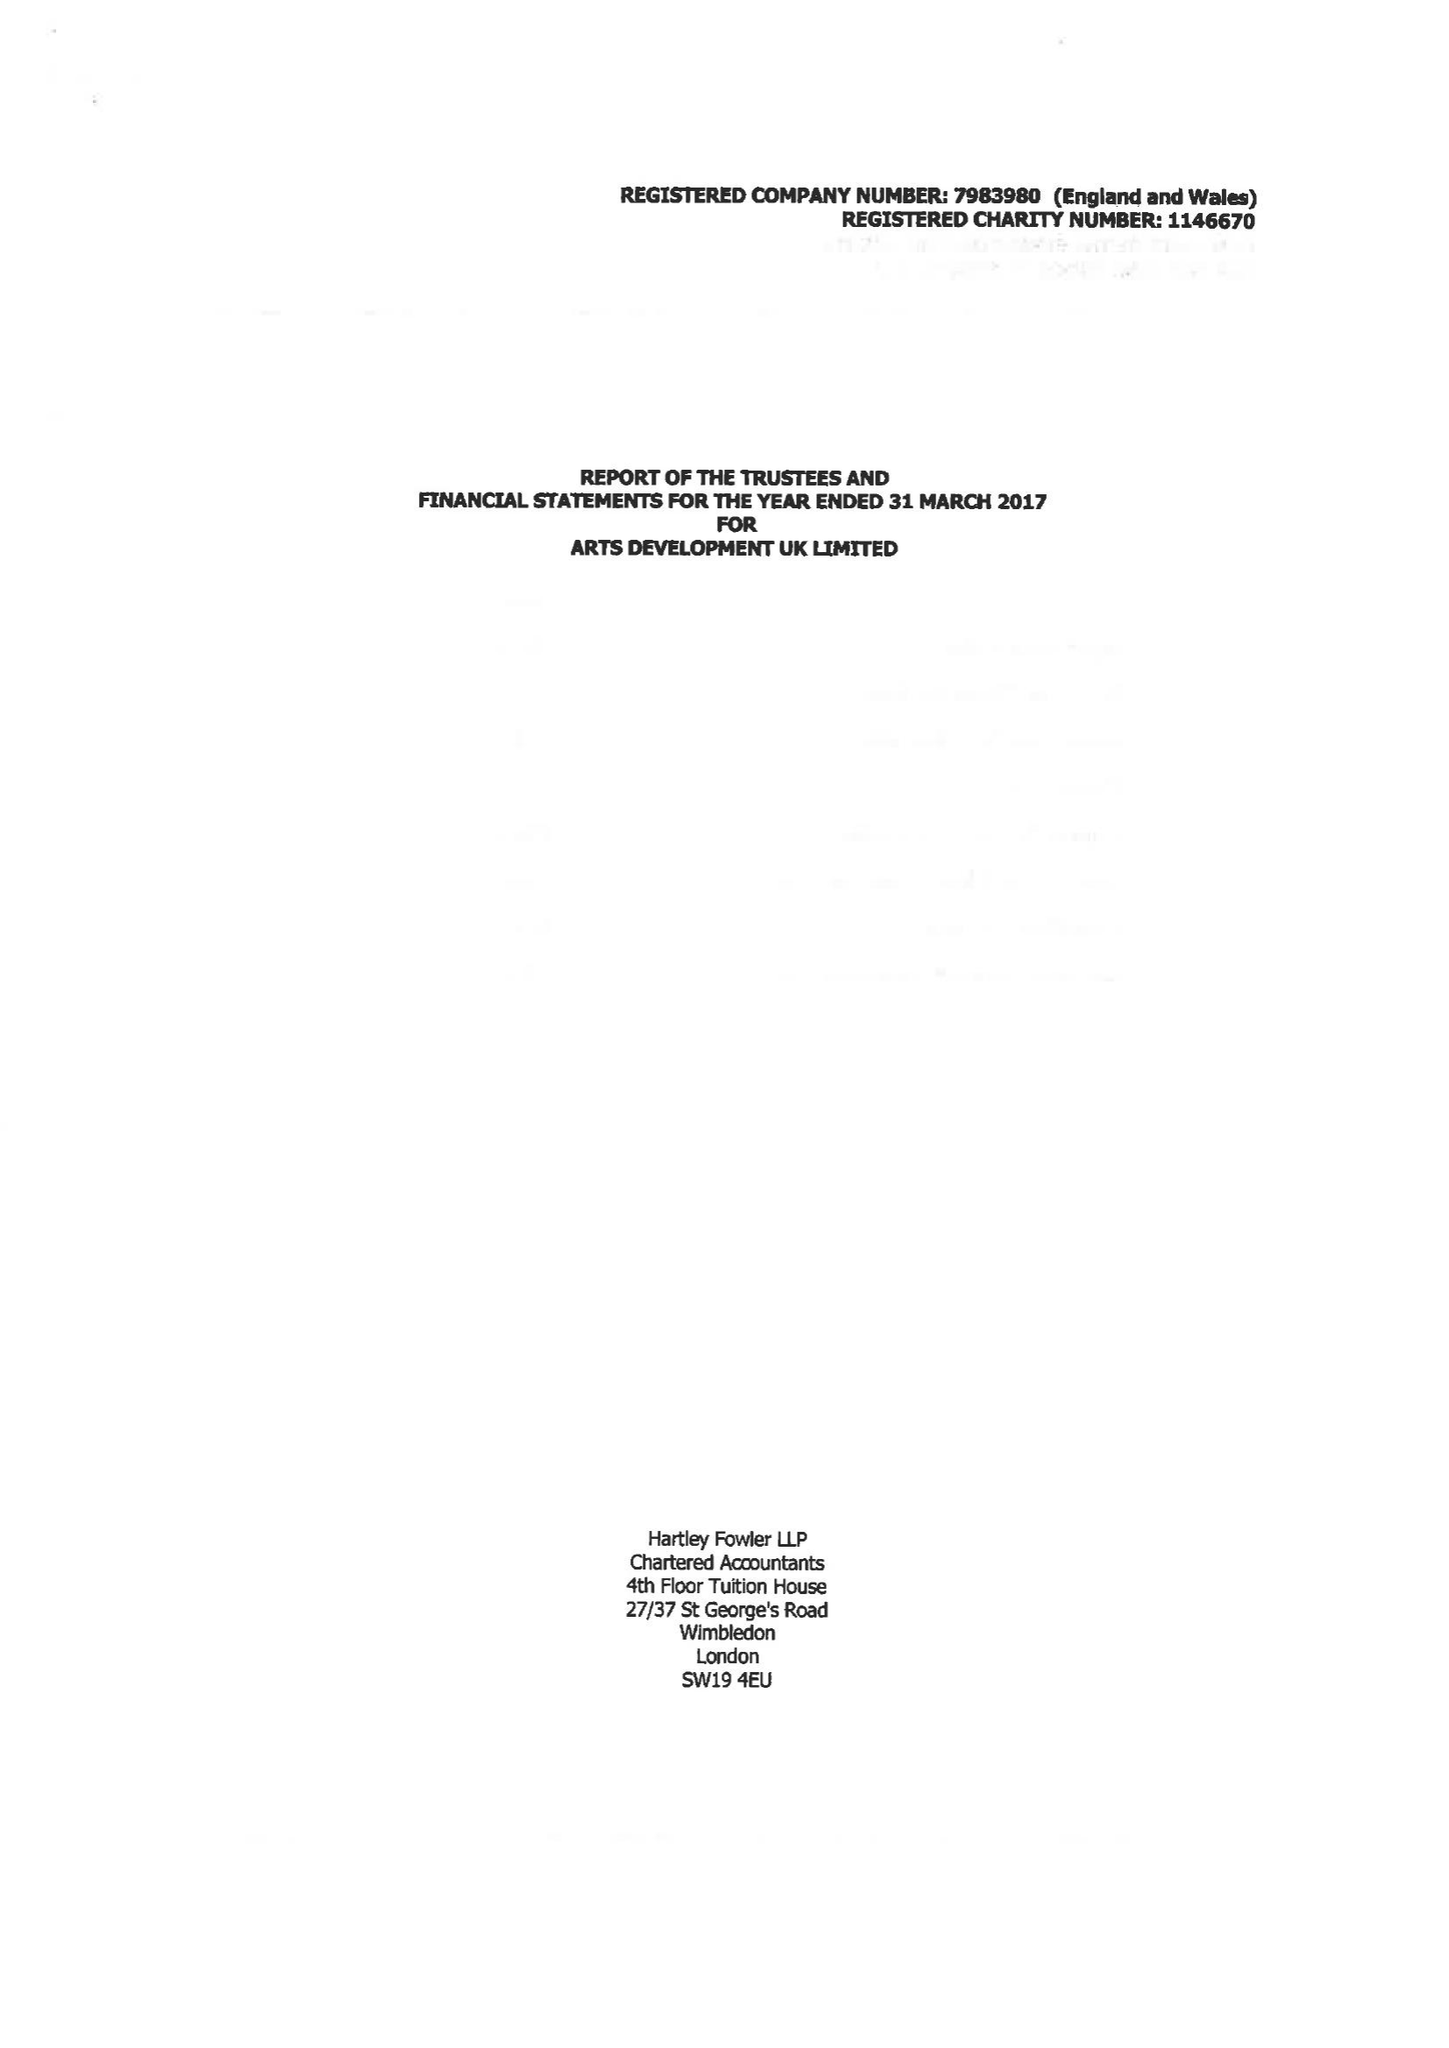What is the value for the charity_name?
Answer the question using a single word or phrase. Arts Development Uk Ltd. 